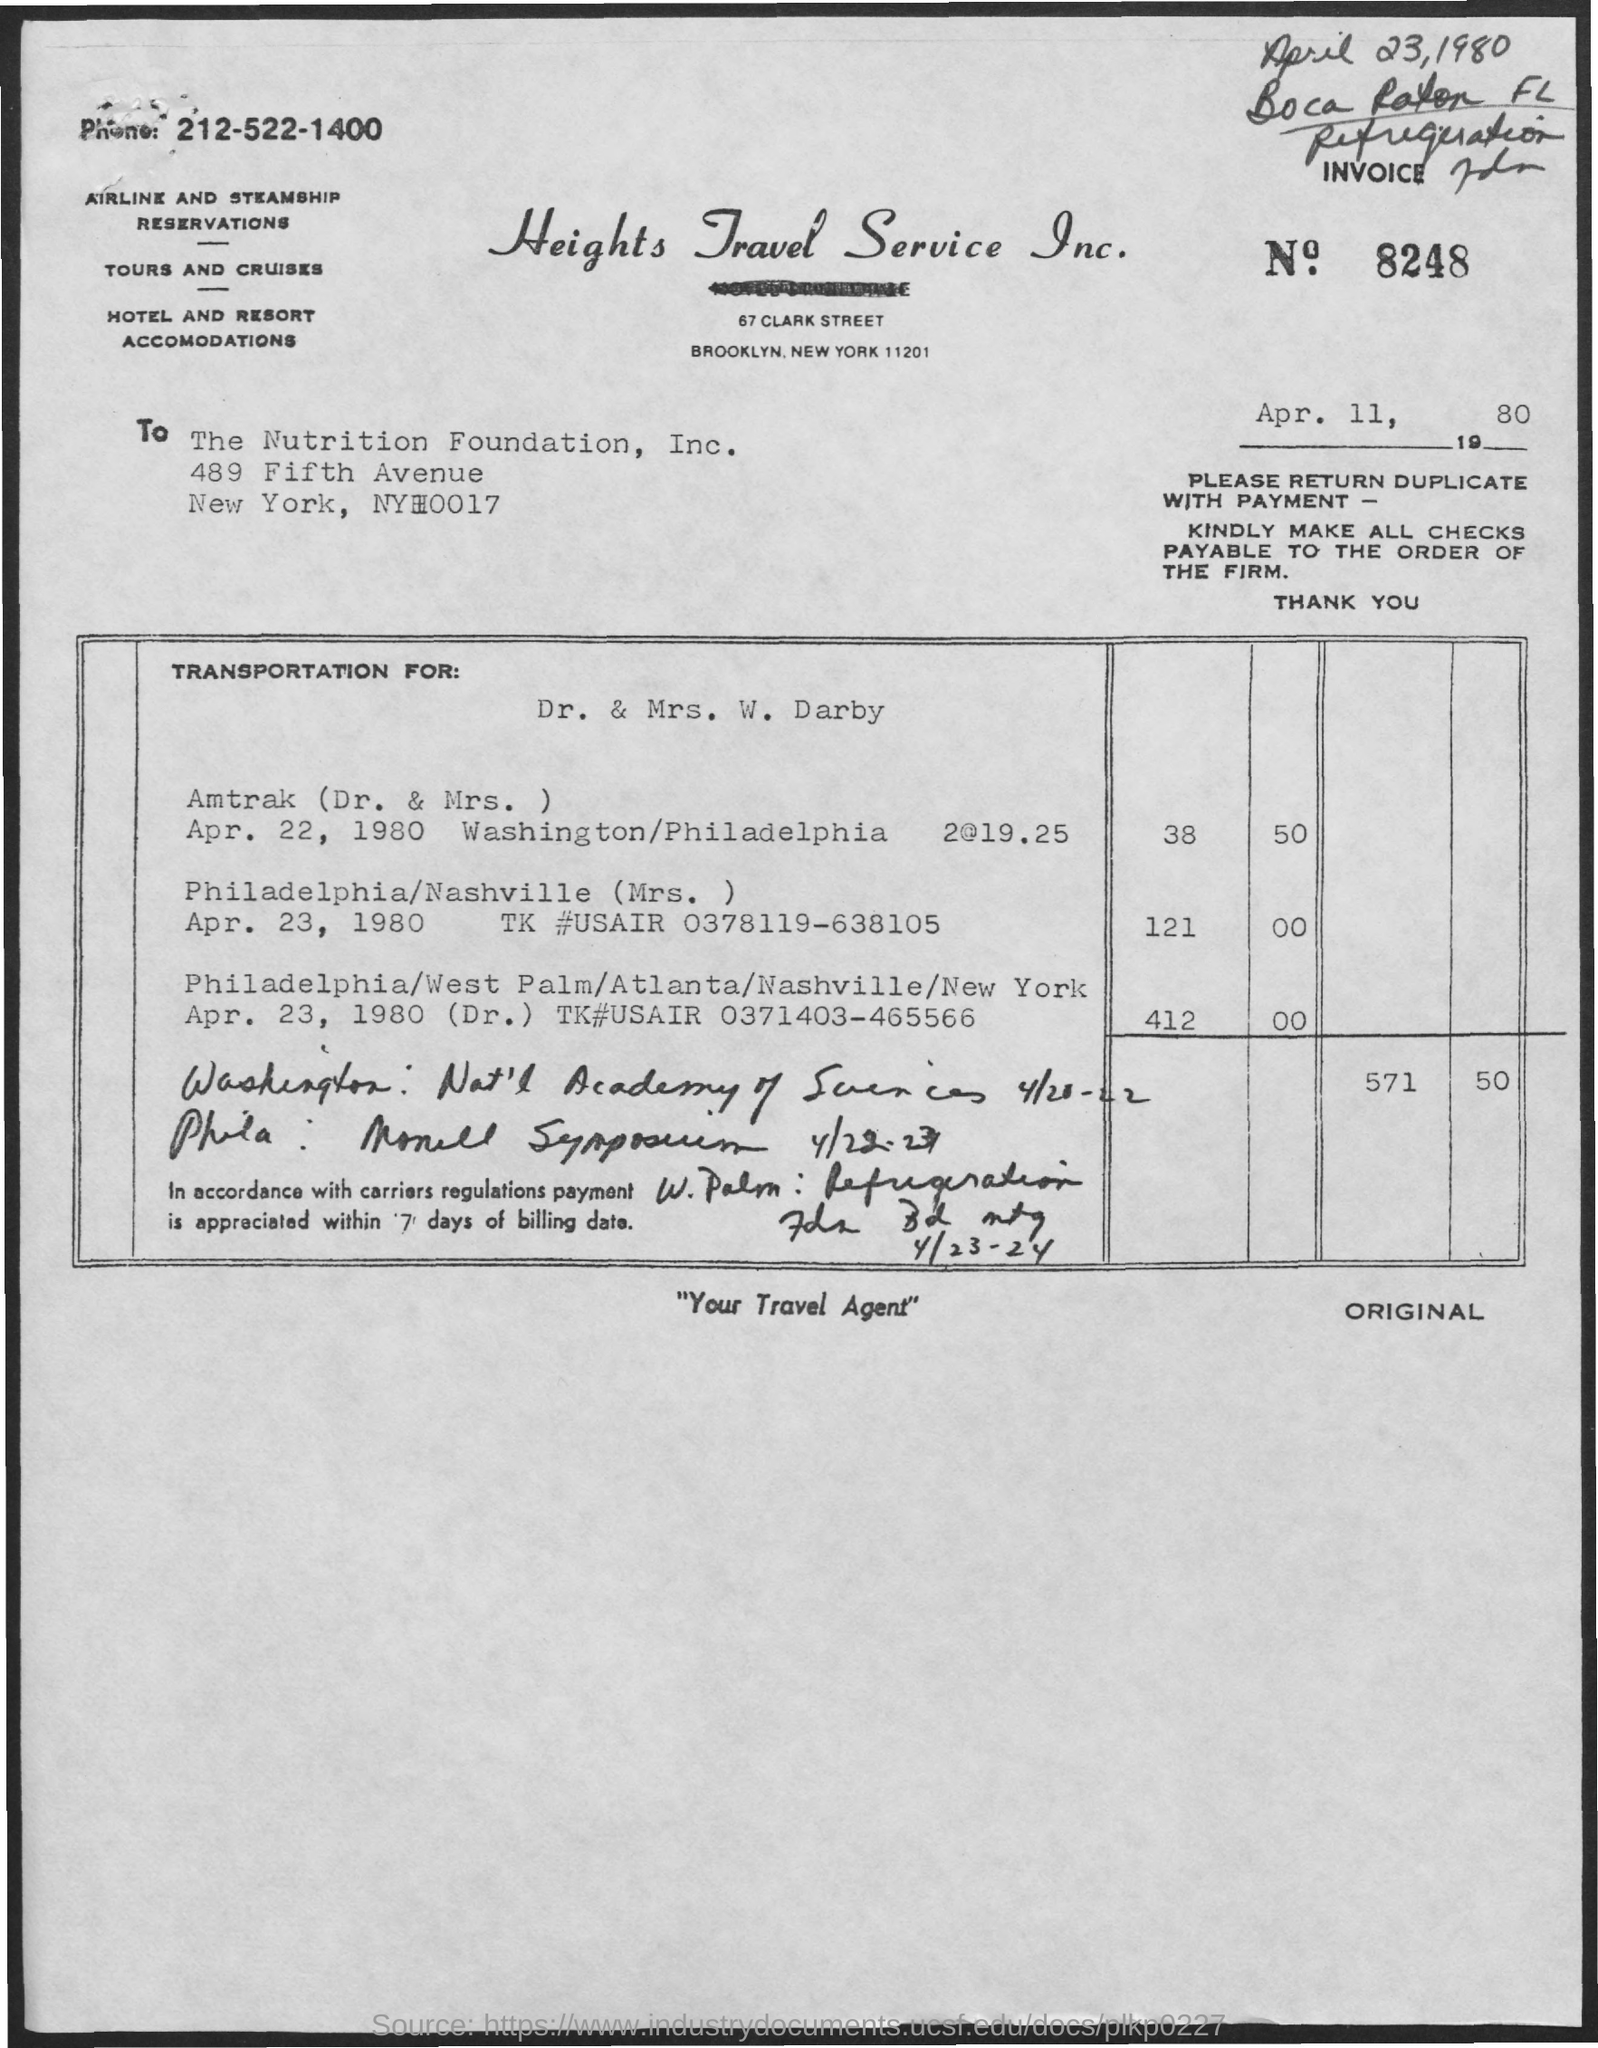What is the name of the travel service?
Offer a very short reply. Heights Travel Service Inc. What is the invoice no?
Your answer should be compact. 8248. What is the date mentioned?
Give a very brief answer. Apr. 11, 1980. 